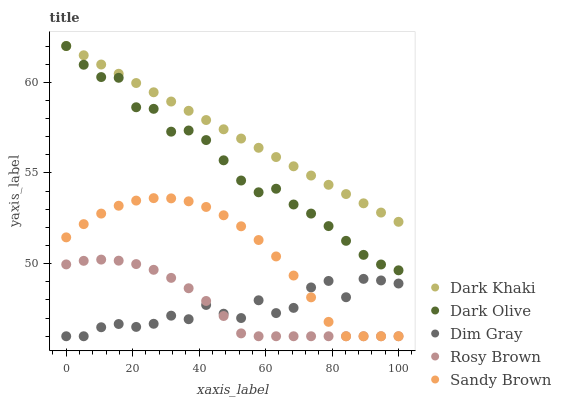Does Dim Gray have the minimum area under the curve?
Answer yes or no. Yes. Does Dark Khaki have the maximum area under the curve?
Answer yes or no. Yes. Does Dark Olive have the minimum area under the curve?
Answer yes or no. No. Does Dark Olive have the maximum area under the curve?
Answer yes or no. No. Is Dark Khaki the smoothest?
Answer yes or no. Yes. Is Dim Gray the roughest?
Answer yes or no. Yes. Is Dark Olive the smoothest?
Answer yes or no. No. Is Dark Olive the roughest?
Answer yes or no. No. Does Dim Gray have the lowest value?
Answer yes or no. Yes. Does Dark Olive have the lowest value?
Answer yes or no. No. Does Dark Olive have the highest value?
Answer yes or no. Yes. Does Dim Gray have the highest value?
Answer yes or no. No. Is Rosy Brown less than Dark Olive?
Answer yes or no. Yes. Is Dark Olive greater than Dim Gray?
Answer yes or no. Yes. Does Sandy Brown intersect Dim Gray?
Answer yes or no. Yes. Is Sandy Brown less than Dim Gray?
Answer yes or no. No. Is Sandy Brown greater than Dim Gray?
Answer yes or no. No. Does Rosy Brown intersect Dark Olive?
Answer yes or no. No. 